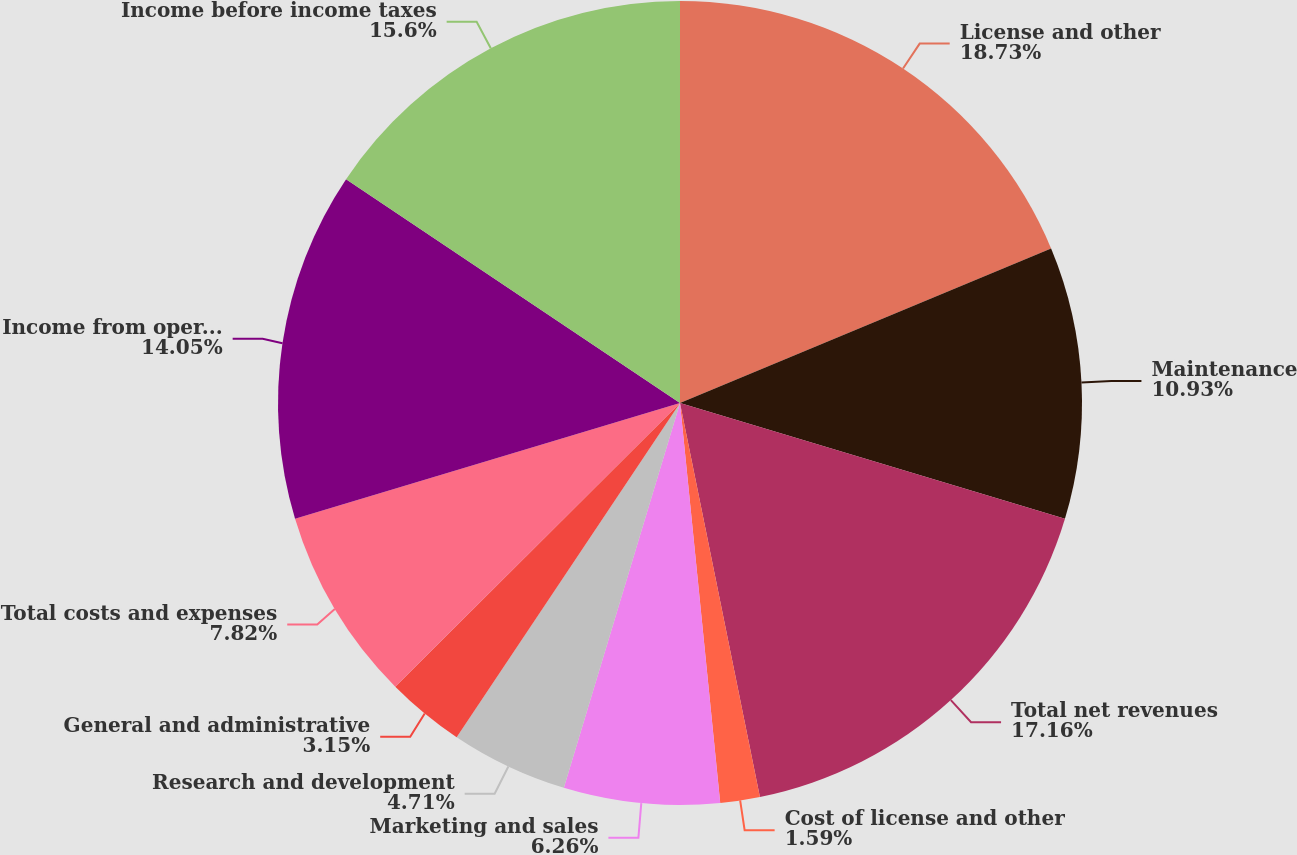Convert chart to OTSL. <chart><loc_0><loc_0><loc_500><loc_500><pie_chart><fcel>License and other<fcel>Maintenance<fcel>Total net revenues<fcel>Cost of license and other<fcel>Marketing and sales<fcel>Research and development<fcel>General and administrative<fcel>Total costs and expenses<fcel>Income from operations<fcel>Income before income taxes<nl><fcel>18.72%<fcel>10.93%<fcel>17.16%<fcel>1.59%<fcel>6.26%<fcel>4.71%<fcel>3.15%<fcel>7.82%<fcel>14.05%<fcel>15.6%<nl></chart> 